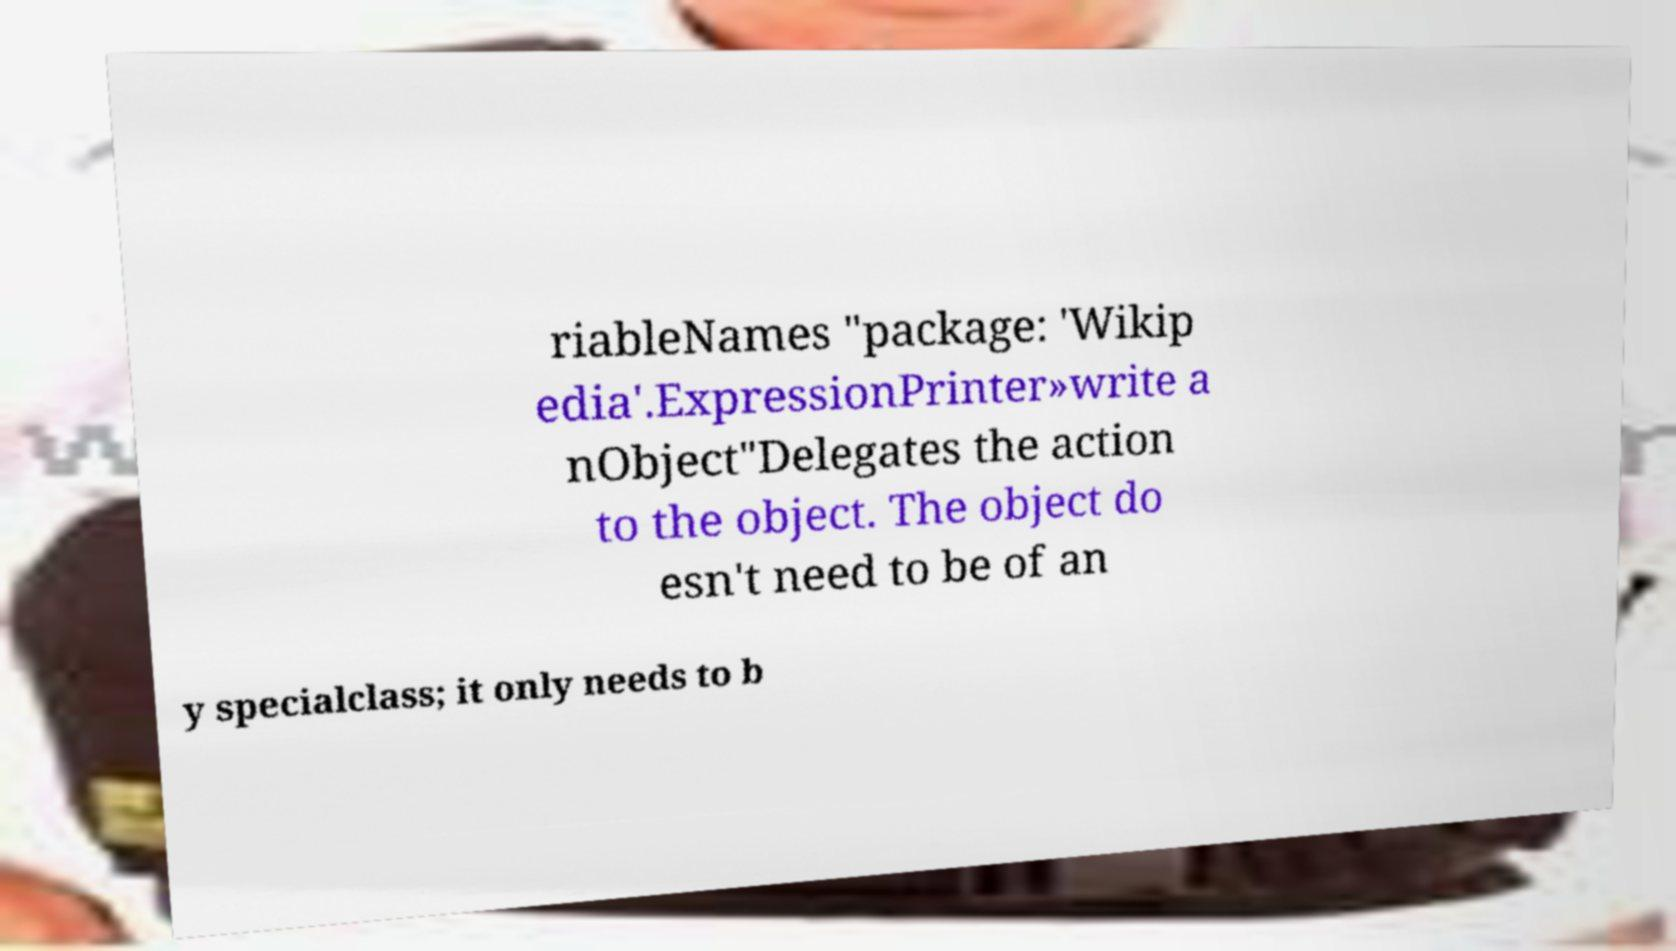Can you read and provide the text displayed in the image?This photo seems to have some interesting text. Can you extract and type it out for me? riableNames "package: 'Wikip edia'.ExpressionPrinter»write a nObject"Delegates the action to the object. The object do esn't need to be of an y specialclass; it only needs to b 